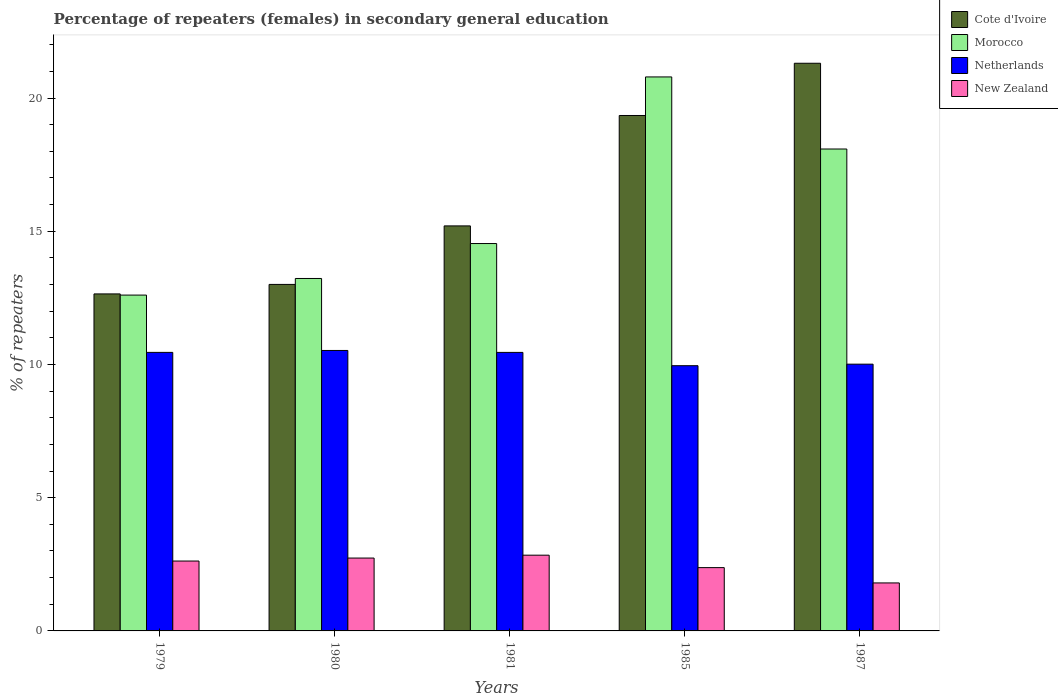How many different coloured bars are there?
Provide a short and direct response. 4. Are the number of bars on each tick of the X-axis equal?
Offer a terse response. Yes. How many bars are there on the 5th tick from the right?
Offer a terse response. 4. What is the label of the 5th group of bars from the left?
Make the answer very short. 1987. What is the percentage of female repeaters in New Zealand in 1987?
Your answer should be compact. 1.8. Across all years, what is the maximum percentage of female repeaters in New Zealand?
Your response must be concise. 2.84. Across all years, what is the minimum percentage of female repeaters in Morocco?
Keep it short and to the point. 12.6. In which year was the percentage of female repeaters in New Zealand maximum?
Provide a succinct answer. 1981. In which year was the percentage of female repeaters in Cote d'Ivoire minimum?
Your answer should be very brief. 1979. What is the total percentage of female repeaters in Cote d'Ivoire in the graph?
Keep it short and to the point. 81.5. What is the difference between the percentage of female repeaters in New Zealand in 1979 and that in 1981?
Ensure brevity in your answer.  -0.22. What is the difference between the percentage of female repeaters in Cote d'Ivoire in 1987 and the percentage of female repeaters in New Zealand in 1980?
Ensure brevity in your answer.  18.57. What is the average percentage of female repeaters in Netherlands per year?
Offer a terse response. 10.28. In the year 1985, what is the difference between the percentage of female repeaters in Cote d'Ivoire and percentage of female repeaters in Morocco?
Offer a terse response. -1.45. What is the ratio of the percentage of female repeaters in Cote d'Ivoire in 1980 to that in 1987?
Keep it short and to the point. 0.61. Is the percentage of female repeaters in Netherlands in 1981 less than that in 1985?
Give a very brief answer. No. What is the difference between the highest and the second highest percentage of female repeaters in New Zealand?
Your response must be concise. 0.11. What is the difference between the highest and the lowest percentage of female repeaters in New Zealand?
Keep it short and to the point. 1.04. Is it the case that in every year, the sum of the percentage of female repeaters in Morocco and percentage of female repeaters in New Zealand is greater than the sum of percentage of female repeaters in Netherlands and percentage of female repeaters in Cote d'Ivoire?
Provide a short and direct response. No. What does the 2nd bar from the left in 1979 represents?
Your answer should be compact. Morocco. What does the 2nd bar from the right in 1980 represents?
Your response must be concise. Netherlands. How many years are there in the graph?
Make the answer very short. 5. What is the difference between two consecutive major ticks on the Y-axis?
Ensure brevity in your answer.  5. Does the graph contain any zero values?
Ensure brevity in your answer.  No. Does the graph contain grids?
Your answer should be compact. No. Where does the legend appear in the graph?
Your answer should be compact. Top right. What is the title of the graph?
Keep it short and to the point. Percentage of repeaters (females) in secondary general education. Does "Tanzania" appear as one of the legend labels in the graph?
Ensure brevity in your answer.  No. What is the label or title of the Y-axis?
Offer a very short reply. % of repeaters. What is the % of repeaters of Cote d'Ivoire in 1979?
Ensure brevity in your answer.  12.65. What is the % of repeaters in Morocco in 1979?
Your response must be concise. 12.6. What is the % of repeaters in Netherlands in 1979?
Your answer should be very brief. 10.45. What is the % of repeaters of New Zealand in 1979?
Ensure brevity in your answer.  2.62. What is the % of repeaters of Cote d'Ivoire in 1980?
Ensure brevity in your answer.  13. What is the % of repeaters of Morocco in 1980?
Offer a very short reply. 13.23. What is the % of repeaters of Netherlands in 1980?
Your response must be concise. 10.53. What is the % of repeaters in New Zealand in 1980?
Provide a short and direct response. 2.73. What is the % of repeaters in Cote d'Ivoire in 1981?
Give a very brief answer. 15.2. What is the % of repeaters in Morocco in 1981?
Your response must be concise. 14.54. What is the % of repeaters of Netherlands in 1981?
Your response must be concise. 10.45. What is the % of repeaters of New Zealand in 1981?
Provide a short and direct response. 2.84. What is the % of repeaters of Cote d'Ivoire in 1985?
Ensure brevity in your answer.  19.34. What is the % of repeaters of Morocco in 1985?
Provide a succinct answer. 20.79. What is the % of repeaters in Netherlands in 1985?
Your answer should be compact. 9.95. What is the % of repeaters in New Zealand in 1985?
Give a very brief answer. 2.38. What is the % of repeaters of Cote d'Ivoire in 1987?
Your answer should be very brief. 21.3. What is the % of repeaters of Morocco in 1987?
Your response must be concise. 18.09. What is the % of repeaters of Netherlands in 1987?
Offer a very short reply. 10.01. What is the % of repeaters of New Zealand in 1987?
Offer a terse response. 1.8. Across all years, what is the maximum % of repeaters of Cote d'Ivoire?
Keep it short and to the point. 21.3. Across all years, what is the maximum % of repeaters in Morocco?
Your answer should be compact. 20.79. Across all years, what is the maximum % of repeaters in Netherlands?
Make the answer very short. 10.53. Across all years, what is the maximum % of repeaters of New Zealand?
Provide a succinct answer. 2.84. Across all years, what is the minimum % of repeaters of Cote d'Ivoire?
Offer a very short reply. 12.65. Across all years, what is the minimum % of repeaters in Morocco?
Offer a terse response. 12.6. Across all years, what is the minimum % of repeaters in Netherlands?
Give a very brief answer. 9.95. Across all years, what is the minimum % of repeaters in New Zealand?
Your answer should be very brief. 1.8. What is the total % of repeaters in Cote d'Ivoire in the graph?
Offer a very short reply. 81.5. What is the total % of repeaters in Morocco in the graph?
Provide a succinct answer. 79.25. What is the total % of repeaters in Netherlands in the graph?
Your answer should be very brief. 51.4. What is the total % of repeaters of New Zealand in the graph?
Make the answer very short. 12.38. What is the difference between the % of repeaters in Cote d'Ivoire in 1979 and that in 1980?
Your answer should be very brief. -0.36. What is the difference between the % of repeaters in Morocco in 1979 and that in 1980?
Give a very brief answer. -0.62. What is the difference between the % of repeaters of Netherlands in 1979 and that in 1980?
Give a very brief answer. -0.07. What is the difference between the % of repeaters in New Zealand in 1979 and that in 1980?
Ensure brevity in your answer.  -0.11. What is the difference between the % of repeaters of Cote d'Ivoire in 1979 and that in 1981?
Your answer should be compact. -2.55. What is the difference between the % of repeaters of Morocco in 1979 and that in 1981?
Offer a terse response. -1.93. What is the difference between the % of repeaters of New Zealand in 1979 and that in 1981?
Offer a very short reply. -0.22. What is the difference between the % of repeaters in Cote d'Ivoire in 1979 and that in 1985?
Keep it short and to the point. -6.7. What is the difference between the % of repeaters in Morocco in 1979 and that in 1985?
Your answer should be very brief. -8.19. What is the difference between the % of repeaters of Netherlands in 1979 and that in 1985?
Offer a very short reply. 0.5. What is the difference between the % of repeaters in New Zealand in 1979 and that in 1985?
Give a very brief answer. 0.25. What is the difference between the % of repeaters of Cote d'Ivoire in 1979 and that in 1987?
Your answer should be compact. -8.66. What is the difference between the % of repeaters in Morocco in 1979 and that in 1987?
Make the answer very short. -5.48. What is the difference between the % of repeaters of Netherlands in 1979 and that in 1987?
Give a very brief answer. 0.44. What is the difference between the % of repeaters of New Zealand in 1979 and that in 1987?
Provide a succinct answer. 0.82. What is the difference between the % of repeaters in Cote d'Ivoire in 1980 and that in 1981?
Your answer should be compact. -2.2. What is the difference between the % of repeaters of Morocco in 1980 and that in 1981?
Your answer should be compact. -1.31. What is the difference between the % of repeaters of Netherlands in 1980 and that in 1981?
Give a very brief answer. 0.07. What is the difference between the % of repeaters in New Zealand in 1980 and that in 1981?
Provide a succinct answer. -0.11. What is the difference between the % of repeaters in Cote d'Ivoire in 1980 and that in 1985?
Your answer should be compact. -6.34. What is the difference between the % of repeaters of Morocco in 1980 and that in 1985?
Provide a succinct answer. -7.56. What is the difference between the % of repeaters of Netherlands in 1980 and that in 1985?
Offer a terse response. 0.57. What is the difference between the % of repeaters of New Zealand in 1980 and that in 1985?
Ensure brevity in your answer.  0.36. What is the difference between the % of repeaters in Cote d'Ivoire in 1980 and that in 1987?
Provide a short and direct response. -8.3. What is the difference between the % of repeaters of Morocco in 1980 and that in 1987?
Your answer should be very brief. -4.86. What is the difference between the % of repeaters of Netherlands in 1980 and that in 1987?
Offer a terse response. 0.51. What is the difference between the % of repeaters of New Zealand in 1980 and that in 1987?
Offer a very short reply. 0.93. What is the difference between the % of repeaters in Cote d'Ivoire in 1981 and that in 1985?
Provide a succinct answer. -4.14. What is the difference between the % of repeaters of Morocco in 1981 and that in 1985?
Your response must be concise. -6.25. What is the difference between the % of repeaters of Netherlands in 1981 and that in 1985?
Your answer should be very brief. 0.5. What is the difference between the % of repeaters of New Zealand in 1981 and that in 1985?
Give a very brief answer. 0.47. What is the difference between the % of repeaters in Cote d'Ivoire in 1981 and that in 1987?
Offer a terse response. -6.1. What is the difference between the % of repeaters in Morocco in 1981 and that in 1987?
Provide a succinct answer. -3.55. What is the difference between the % of repeaters of Netherlands in 1981 and that in 1987?
Ensure brevity in your answer.  0.44. What is the difference between the % of repeaters in New Zealand in 1981 and that in 1987?
Ensure brevity in your answer.  1.04. What is the difference between the % of repeaters in Cote d'Ivoire in 1985 and that in 1987?
Your response must be concise. -1.96. What is the difference between the % of repeaters of Morocco in 1985 and that in 1987?
Your answer should be compact. 2.71. What is the difference between the % of repeaters of Netherlands in 1985 and that in 1987?
Give a very brief answer. -0.06. What is the difference between the % of repeaters of New Zealand in 1985 and that in 1987?
Ensure brevity in your answer.  0.57. What is the difference between the % of repeaters in Cote d'Ivoire in 1979 and the % of repeaters in Morocco in 1980?
Ensure brevity in your answer.  -0.58. What is the difference between the % of repeaters in Cote d'Ivoire in 1979 and the % of repeaters in Netherlands in 1980?
Make the answer very short. 2.12. What is the difference between the % of repeaters in Cote d'Ivoire in 1979 and the % of repeaters in New Zealand in 1980?
Your answer should be compact. 9.91. What is the difference between the % of repeaters in Morocco in 1979 and the % of repeaters in Netherlands in 1980?
Your response must be concise. 2.08. What is the difference between the % of repeaters in Morocco in 1979 and the % of repeaters in New Zealand in 1980?
Your answer should be very brief. 9.87. What is the difference between the % of repeaters in Netherlands in 1979 and the % of repeaters in New Zealand in 1980?
Offer a terse response. 7.72. What is the difference between the % of repeaters in Cote d'Ivoire in 1979 and the % of repeaters in Morocco in 1981?
Your response must be concise. -1.89. What is the difference between the % of repeaters of Cote d'Ivoire in 1979 and the % of repeaters of Netherlands in 1981?
Your response must be concise. 2.19. What is the difference between the % of repeaters of Cote d'Ivoire in 1979 and the % of repeaters of New Zealand in 1981?
Your answer should be very brief. 9.81. What is the difference between the % of repeaters of Morocco in 1979 and the % of repeaters of Netherlands in 1981?
Your answer should be compact. 2.15. What is the difference between the % of repeaters in Morocco in 1979 and the % of repeaters in New Zealand in 1981?
Your answer should be very brief. 9.76. What is the difference between the % of repeaters of Netherlands in 1979 and the % of repeaters of New Zealand in 1981?
Provide a succinct answer. 7.61. What is the difference between the % of repeaters in Cote d'Ivoire in 1979 and the % of repeaters in Morocco in 1985?
Provide a succinct answer. -8.14. What is the difference between the % of repeaters of Cote d'Ivoire in 1979 and the % of repeaters of Netherlands in 1985?
Your response must be concise. 2.69. What is the difference between the % of repeaters in Cote d'Ivoire in 1979 and the % of repeaters in New Zealand in 1985?
Your answer should be compact. 10.27. What is the difference between the % of repeaters in Morocco in 1979 and the % of repeaters in Netherlands in 1985?
Your answer should be compact. 2.65. What is the difference between the % of repeaters of Morocco in 1979 and the % of repeaters of New Zealand in 1985?
Ensure brevity in your answer.  10.23. What is the difference between the % of repeaters in Netherlands in 1979 and the % of repeaters in New Zealand in 1985?
Make the answer very short. 8.08. What is the difference between the % of repeaters of Cote d'Ivoire in 1979 and the % of repeaters of Morocco in 1987?
Your response must be concise. -5.44. What is the difference between the % of repeaters in Cote d'Ivoire in 1979 and the % of repeaters in Netherlands in 1987?
Your response must be concise. 2.64. What is the difference between the % of repeaters in Cote d'Ivoire in 1979 and the % of repeaters in New Zealand in 1987?
Your answer should be compact. 10.85. What is the difference between the % of repeaters in Morocco in 1979 and the % of repeaters in Netherlands in 1987?
Provide a succinct answer. 2.59. What is the difference between the % of repeaters in Morocco in 1979 and the % of repeaters in New Zealand in 1987?
Your answer should be compact. 10.8. What is the difference between the % of repeaters in Netherlands in 1979 and the % of repeaters in New Zealand in 1987?
Ensure brevity in your answer.  8.65. What is the difference between the % of repeaters of Cote d'Ivoire in 1980 and the % of repeaters of Morocco in 1981?
Make the answer very short. -1.53. What is the difference between the % of repeaters in Cote d'Ivoire in 1980 and the % of repeaters in Netherlands in 1981?
Keep it short and to the point. 2.55. What is the difference between the % of repeaters in Cote d'Ivoire in 1980 and the % of repeaters in New Zealand in 1981?
Offer a terse response. 10.16. What is the difference between the % of repeaters in Morocco in 1980 and the % of repeaters in Netherlands in 1981?
Provide a short and direct response. 2.77. What is the difference between the % of repeaters of Morocco in 1980 and the % of repeaters of New Zealand in 1981?
Offer a terse response. 10.38. What is the difference between the % of repeaters of Netherlands in 1980 and the % of repeaters of New Zealand in 1981?
Your response must be concise. 7.68. What is the difference between the % of repeaters in Cote d'Ivoire in 1980 and the % of repeaters in Morocco in 1985?
Keep it short and to the point. -7.79. What is the difference between the % of repeaters of Cote d'Ivoire in 1980 and the % of repeaters of Netherlands in 1985?
Give a very brief answer. 3.05. What is the difference between the % of repeaters in Cote d'Ivoire in 1980 and the % of repeaters in New Zealand in 1985?
Your answer should be compact. 10.63. What is the difference between the % of repeaters in Morocco in 1980 and the % of repeaters in Netherlands in 1985?
Your answer should be compact. 3.27. What is the difference between the % of repeaters in Morocco in 1980 and the % of repeaters in New Zealand in 1985?
Ensure brevity in your answer.  10.85. What is the difference between the % of repeaters in Netherlands in 1980 and the % of repeaters in New Zealand in 1985?
Keep it short and to the point. 8.15. What is the difference between the % of repeaters in Cote d'Ivoire in 1980 and the % of repeaters in Morocco in 1987?
Give a very brief answer. -5.08. What is the difference between the % of repeaters in Cote d'Ivoire in 1980 and the % of repeaters in Netherlands in 1987?
Offer a very short reply. 2.99. What is the difference between the % of repeaters of Cote d'Ivoire in 1980 and the % of repeaters of New Zealand in 1987?
Give a very brief answer. 11.2. What is the difference between the % of repeaters of Morocco in 1980 and the % of repeaters of Netherlands in 1987?
Provide a short and direct response. 3.22. What is the difference between the % of repeaters of Morocco in 1980 and the % of repeaters of New Zealand in 1987?
Provide a short and direct response. 11.43. What is the difference between the % of repeaters in Netherlands in 1980 and the % of repeaters in New Zealand in 1987?
Provide a succinct answer. 8.72. What is the difference between the % of repeaters in Cote d'Ivoire in 1981 and the % of repeaters in Morocco in 1985?
Provide a short and direct response. -5.59. What is the difference between the % of repeaters in Cote d'Ivoire in 1981 and the % of repeaters in Netherlands in 1985?
Offer a very short reply. 5.25. What is the difference between the % of repeaters of Cote d'Ivoire in 1981 and the % of repeaters of New Zealand in 1985?
Give a very brief answer. 12.82. What is the difference between the % of repeaters in Morocco in 1981 and the % of repeaters in Netherlands in 1985?
Give a very brief answer. 4.58. What is the difference between the % of repeaters of Morocco in 1981 and the % of repeaters of New Zealand in 1985?
Your answer should be compact. 12.16. What is the difference between the % of repeaters in Netherlands in 1981 and the % of repeaters in New Zealand in 1985?
Your answer should be very brief. 8.08. What is the difference between the % of repeaters of Cote d'Ivoire in 1981 and the % of repeaters of Morocco in 1987?
Make the answer very short. -2.89. What is the difference between the % of repeaters of Cote d'Ivoire in 1981 and the % of repeaters of Netherlands in 1987?
Provide a succinct answer. 5.19. What is the difference between the % of repeaters of Cote d'Ivoire in 1981 and the % of repeaters of New Zealand in 1987?
Your answer should be very brief. 13.4. What is the difference between the % of repeaters of Morocco in 1981 and the % of repeaters of Netherlands in 1987?
Your answer should be very brief. 4.53. What is the difference between the % of repeaters of Morocco in 1981 and the % of repeaters of New Zealand in 1987?
Ensure brevity in your answer.  12.74. What is the difference between the % of repeaters in Netherlands in 1981 and the % of repeaters in New Zealand in 1987?
Your answer should be very brief. 8.65. What is the difference between the % of repeaters in Cote d'Ivoire in 1985 and the % of repeaters in Morocco in 1987?
Offer a terse response. 1.26. What is the difference between the % of repeaters in Cote d'Ivoire in 1985 and the % of repeaters in Netherlands in 1987?
Make the answer very short. 9.33. What is the difference between the % of repeaters in Cote d'Ivoire in 1985 and the % of repeaters in New Zealand in 1987?
Offer a terse response. 17.54. What is the difference between the % of repeaters of Morocco in 1985 and the % of repeaters of Netherlands in 1987?
Give a very brief answer. 10.78. What is the difference between the % of repeaters in Morocco in 1985 and the % of repeaters in New Zealand in 1987?
Make the answer very short. 18.99. What is the difference between the % of repeaters of Netherlands in 1985 and the % of repeaters of New Zealand in 1987?
Give a very brief answer. 8.15. What is the average % of repeaters of Cote d'Ivoire per year?
Provide a succinct answer. 16.3. What is the average % of repeaters in Morocco per year?
Make the answer very short. 15.85. What is the average % of repeaters in Netherlands per year?
Give a very brief answer. 10.28. What is the average % of repeaters of New Zealand per year?
Give a very brief answer. 2.48. In the year 1979, what is the difference between the % of repeaters of Cote d'Ivoire and % of repeaters of Morocco?
Offer a very short reply. 0.04. In the year 1979, what is the difference between the % of repeaters in Cote d'Ivoire and % of repeaters in Netherlands?
Offer a very short reply. 2.19. In the year 1979, what is the difference between the % of repeaters of Cote d'Ivoire and % of repeaters of New Zealand?
Your response must be concise. 10.03. In the year 1979, what is the difference between the % of repeaters of Morocco and % of repeaters of Netherlands?
Give a very brief answer. 2.15. In the year 1979, what is the difference between the % of repeaters of Morocco and % of repeaters of New Zealand?
Provide a succinct answer. 9.98. In the year 1979, what is the difference between the % of repeaters in Netherlands and % of repeaters in New Zealand?
Offer a very short reply. 7.83. In the year 1980, what is the difference between the % of repeaters of Cote d'Ivoire and % of repeaters of Morocco?
Offer a terse response. -0.22. In the year 1980, what is the difference between the % of repeaters in Cote d'Ivoire and % of repeaters in Netherlands?
Provide a succinct answer. 2.48. In the year 1980, what is the difference between the % of repeaters in Cote d'Ivoire and % of repeaters in New Zealand?
Offer a terse response. 10.27. In the year 1980, what is the difference between the % of repeaters in Morocco and % of repeaters in Netherlands?
Ensure brevity in your answer.  2.7. In the year 1980, what is the difference between the % of repeaters of Morocco and % of repeaters of New Zealand?
Keep it short and to the point. 10.49. In the year 1980, what is the difference between the % of repeaters of Netherlands and % of repeaters of New Zealand?
Provide a short and direct response. 7.79. In the year 1981, what is the difference between the % of repeaters in Cote d'Ivoire and % of repeaters in Morocco?
Offer a terse response. 0.66. In the year 1981, what is the difference between the % of repeaters of Cote d'Ivoire and % of repeaters of Netherlands?
Provide a short and direct response. 4.75. In the year 1981, what is the difference between the % of repeaters of Cote d'Ivoire and % of repeaters of New Zealand?
Your answer should be compact. 12.36. In the year 1981, what is the difference between the % of repeaters of Morocco and % of repeaters of Netherlands?
Your answer should be compact. 4.09. In the year 1981, what is the difference between the % of repeaters in Morocco and % of repeaters in New Zealand?
Offer a very short reply. 11.7. In the year 1981, what is the difference between the % of repeaters in Netherlands and % of repeaters in New Zealand?
Provide a short and direct response. 7.61. In the year 1985, what is the difference between the % of repeaters in Cote d'Ivoire and % of repeaters in Morocco?
Offer a terse response. -1.45. In the year 1985, what is the difference between the % of repeaters of Cote d'Ivoire and % of repeaters of Netherlands?
Offer a terse response. 9.39. In the year 1985, what is the difference between the % of repeaters of Cote d'Ivoire and % of repeaters of New Zealand?
Your answer should be very brief. 16.97. In the year 1985, what is the difference between the % of repeaters in Morocco and % of repeaters in Netherlands?
Offer a terse response. 10.84. In the year 1985, what is the difference between the % of repeaters of Morocco and % of repeaters of New Zealand?
Your answer should be compact. 18.42. In the year 1985, what is the difference between the % of repeaters in Netherlands and % of repeaters in New Zealand?
Your answer should be very brief. 7.58. In the year 1987, what is the difference between the % of repeaters in Cote d'Ivoire and % of repeaters in Morocco?
Give a very brief answer. 3.22. In the year 1987, what is the difference between the % of repeaters in Cote d'Ivoire and % of repeaters in Netherlands?
Give a very brief answer. 11.29. In the year 1987, what is the difference between the % of repeaters in Cote d'Ivoire and % of repeaters in New Zealand?
Your answer should be very brief. 19.5. In the year 1987, what is the difference between the % of repeaters in Morocco and % of repeaters in Netherlands?
Offer a terse response. 8.07. In the year 1987, what is the difference between the % of repeaters in Morocco and % of repeaters in New Zealand?
Ensure brevity in your answer.  16.29. In the year 1987, what is the difference between the % of repeaters in Netherlands and % of repeaters in New Zealand?
Your answer should be compact. 8.21. What is the ratio of the % of repeaters in Cote d'Ivoire in 1979 to that in 1980?
Make the answer very short. 0.97. What is the ratio of the % of repeaters of Morocco in 1979 to that in 1980?
Your answer should be compact. 0.95. What is the ratio of the % of repeaters of Cote d'Ivoire in 1979 to that in 1981?
Offer a terse response. 0.83. What is the ratio of the % of repeaters of Morocco in 1979 to that in 1981?
Your answer should be very brief. 0.87. What is the ratio of the % of repeaters in New Zealand in 1979 to that in 1981?
Offer a terse response. 0.92. What is the ratio of the % of repeaters of Cote d'Ivoire in 1979 to that in 1985?
Offer a very short reply. 0.65. What is the ratio of the % of repeaters of Morocco in 1979 to that in 1985?
Provide a succinct answer. 0.61. What is the ratio of the % of repeaters of Netherlands in 1979 to that in 1985?
Your answer should be compact. 1.05. What is the ratio of the % of repeaters in New Zealand in 1979 to that in 1985?
Provide a succinct answer. 1.1. What is the ratio of the % of repeaters of Cote d'Ivoire in 1979 to that in 1987?
Make the answer very short. 0.59. What is the ratio of the % of repeaters in Morocco in 1979 to that in 1987?
Give a very brief answer. 0.7. What is the ratio of the % of repeaters of Netherlands in 1979 to that in 1987?
Offer a very short reply. 1.04. What is the ratio of the % of repeaters of New Zealand in 1979 to that in 1987?
Provide a short and direct response. 1.46. What is the ratio of the % of repeaters of Cote d'Ivoire in 1980 to that in 1981?
Make the answer very short. 0.86. What is the ratio of the % of repeaters of Morocco in 1980 to that in 1981?
Offer a terse response. 0.91. What is the ratio of the % of repeaters in Netherlands in 1980 to that in 1981?
Provide a succinct answer. 1.01. What is the ratio of the % of repeaters in New Zealand in 1980 to that in 1981?
Your answer should be very brief. 0.96. What is the ratio of the % of repeaters in Cote d'Ivoire in 1980 to that in 1985?
Ensure brevity in your answer.  0.67. What is the ratio of the % of repeaters of Morocco in 1980 to that in 1985?
Offer a terse response. 0.64. What is the ratio of the % of repeaters of Netherlands in 1980 to that in 1985?
Offer a very short reply. 1.06. What is the ratio of the % of repeaters of New Zealand in 1980 to that in 1985?
Your response must be concise. 1.15. What is the ratio of the % of repeaters in Cote d'Ivoire in 1980 to that in 1987?
Provide a short and direct response. 0.61. What is the ratio of the % of repeaters of Morocco in 1980 to that in 1987?
Keep it short and to the point. 0.73. What is the ratio of the % of repeaters of Netherlands in 1980 to that in 1987?
Your answer should be compact. 1.05. What is the ratio of the % of repeaters in New Zealand in 1980 to that in 1987?
Provide a succinct answer. 1.52. What is the ratio of the % of repeaters in Cote d'Ivoire in 1981 to that in 1985?
Make the answer very short. 0.79. What is the ratio of the % of repeaters in Morocco in 1981 to that in 1985?
Your response must be concise. 0.7. What is the ratio of the % of repeaters of Netherlands in 1981 to that in 1985?
Your answer should be compact. 1.05. What is the ratio of the % of repeaters in New Zealand in 1981 to that in 1985?
Your answer should be very brief. 1.2. What is the ratio of the % of repeaters in Cote d'Ivoire in 1981 to that in 1987?
Give a very brief answer. 0.71. What is the ratio of the % of repeaters of Morocco in 1981 to that in 1987?
Offer a terse response. 0.8. What is the ratio of the % of repeaters of Netherlands in 1981 to that in 1987?
Make the answer very short. 1.04. What is the ratio of the % of repeaters of New Zealand in 1981 to that in 1987?
Ensure brevity in your answer.  1.58. What is the ratio of the % of repeaters of Cote d'Ivoire in 1985 to that in 1987?
Keep it short and to the point. 0.91. What is the ratio of the % of repeaters of Morocco in 1985 to that in 1987?
Offer a terse response. 1.15. What is the ratio of the % of repeaters of New Zealand in 1985 to that in 1987?
Ensure brevity in your answer.  1.32. What is the difference between the highest and the second highest % of repeaters of Cote d'Ivoire?
Your answer should be very brief. 1.96. What is the difference between the highest and the second highest % of repeaters of Morocco?
Give a very brief answer. 2.71. What is the difference between the highest and the second highest % of repeaters of Netherlands?
Your answer should be very brief. 0.07. What is the difference between the highest and the second highest % of repeaters in New Zealand?
Provide a short and direct response. 0.11. What is the difference between the highest and the lowest % of repeaters of Cote d'Ivoire?
Offer a very short reply. 8.66. What is the difference between the highest and the lowest % of repeaters of Morocco?
Make the answer very short. 8.19. What is the difference between the highest and the lowest % of repeaters in Netherlands?
Ensure brevity in your answer.  0.57. What is the difference between the highest and the lowest % of repeaters in New Zealand?
Provide a short and direct response. 1.04. 